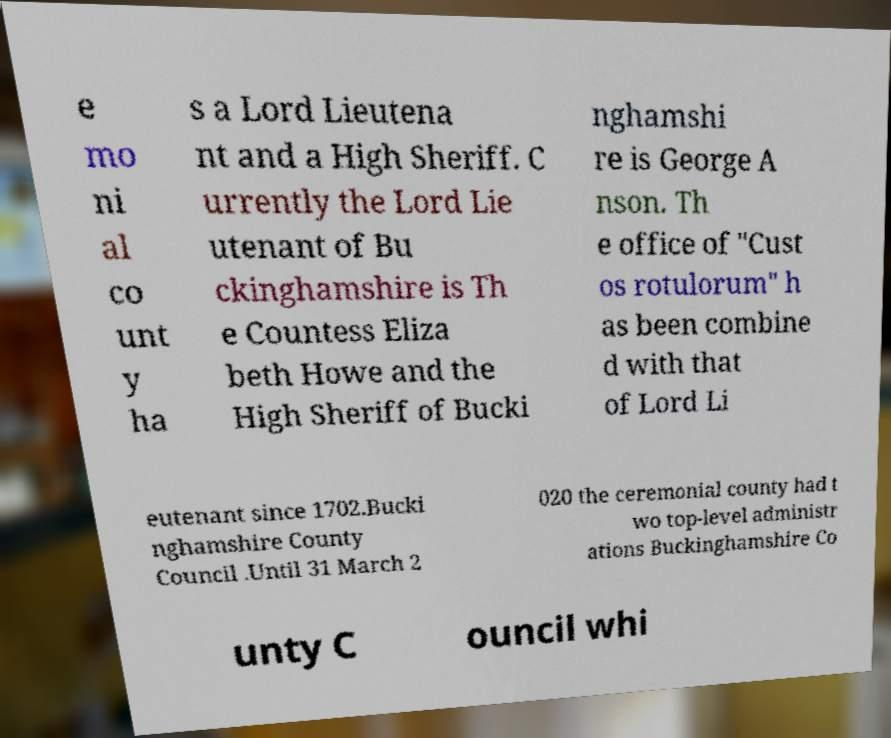Can you accurately transcribe the text from the provided image for me? e mo ni al co unt y ha s a Lord Lieutena nt and a High Sheriff. C urrently the Lord Lie utenant of Bu ckinghamshire is Th e Countess Eliza beth Howe and the High Sheriff of Bucki nghamshi re is George A nson. Th e office of "Cust os rotulorum" h as been combine d with that of Lord Li eutenant since 1702.Bucki nghamshire County Council .Until 31 March 2 020 the ceremonial county had t wo top-level administr ations Buckinghamshire Co unty C ouncil whi 